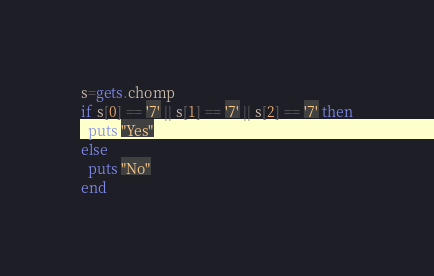Convert code to text. <code><loc_0><loc_0><loc_500><loc_500><_Ruby_>s=gets.chomp
if s[0] == '7' || s[1] == '7' || s[2] == '7' then
  puts "Yes"
else
  puts "No"
end
</code> 